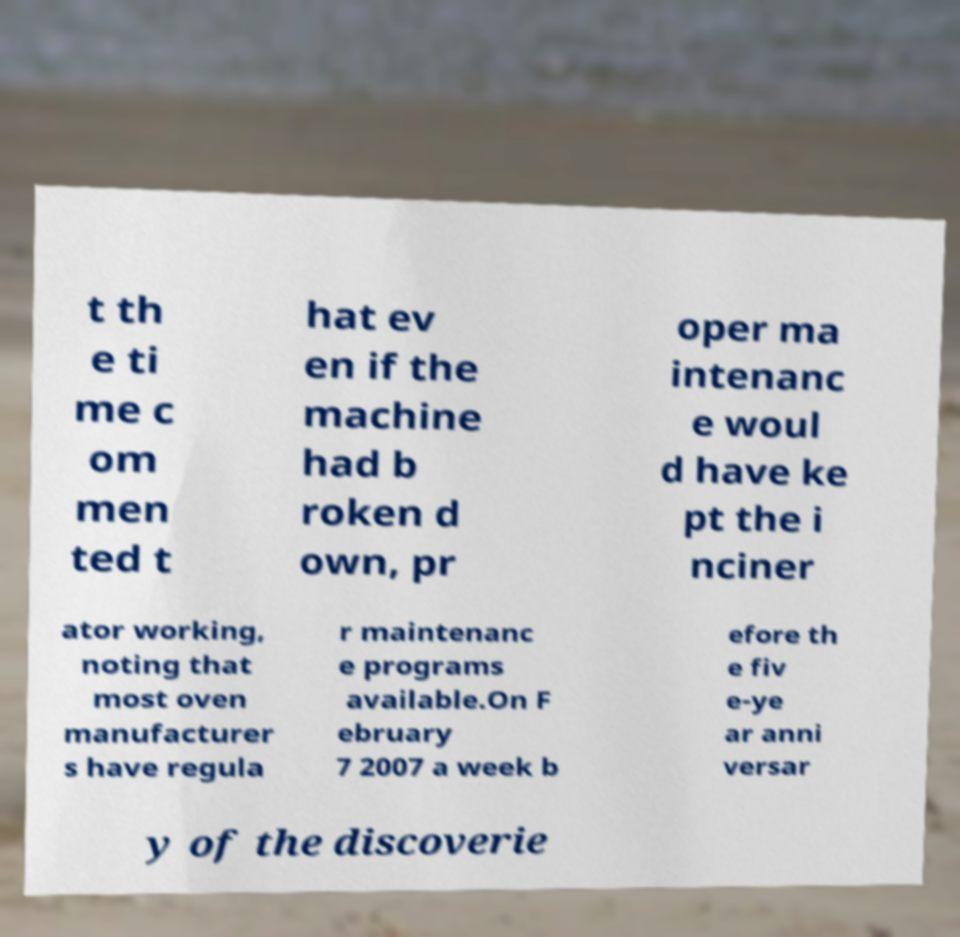Please identify and transcribe the text found in this image. t th e ti me c om men ted t hat ev en if the machine had b roken d own, pr oper ma intenanc e woul d have ke pt the i nciner ator working, noting that most oven manufacturer s have regula r maintenanc e programs available.On F ebruary 7 2007 a week b efore th e fiv e-ye ar anni versar y of the discoverie 